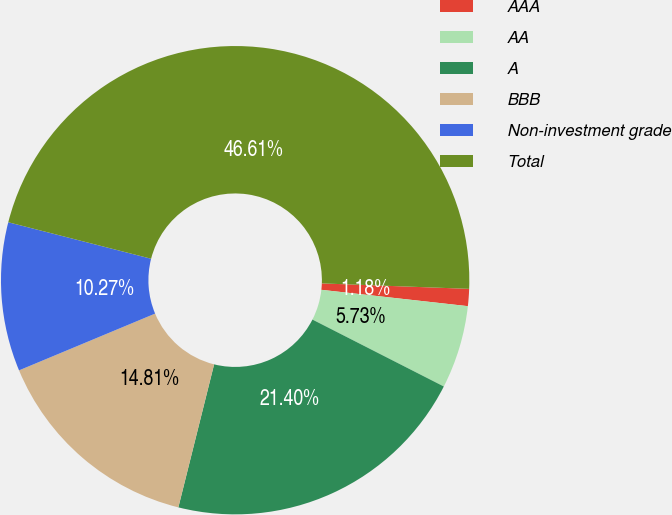Convert chart. <chart><loc_0><loc_0><loc_500><loc_500><pie_chart><fcel>AAA<fcel>AA<fcel>A<fcel>BBB<fcel>Non-investment grade<fcel>Total<nl><fcel>1.18%<fcel>5.73%<fcel>21.4%<fcel>14.81%<fcel>10.27%<fcel>46.61%<nl></chart> 